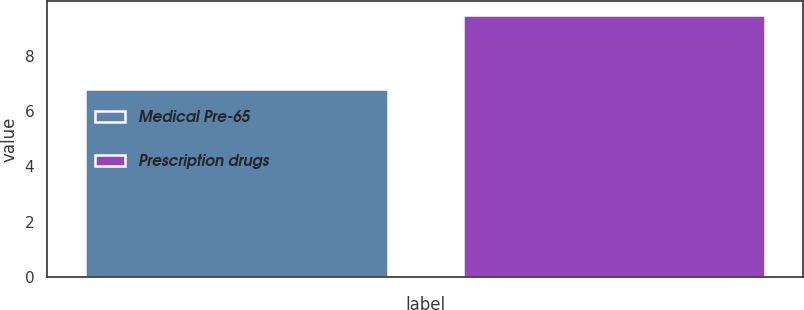Convert chart to OTSL. <chart><loc_0><loc_0><loc_500><loc_500><bar_chart><fcel>Medical Pre-65<fcel>Prescription drugs<nl><fcel>6.8<fcel>9.5<nl></chart> 